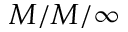Convert formula to latex. <formula><loc_0><loc_0><loc_500><loc_500>M / M / \infty</formula> 